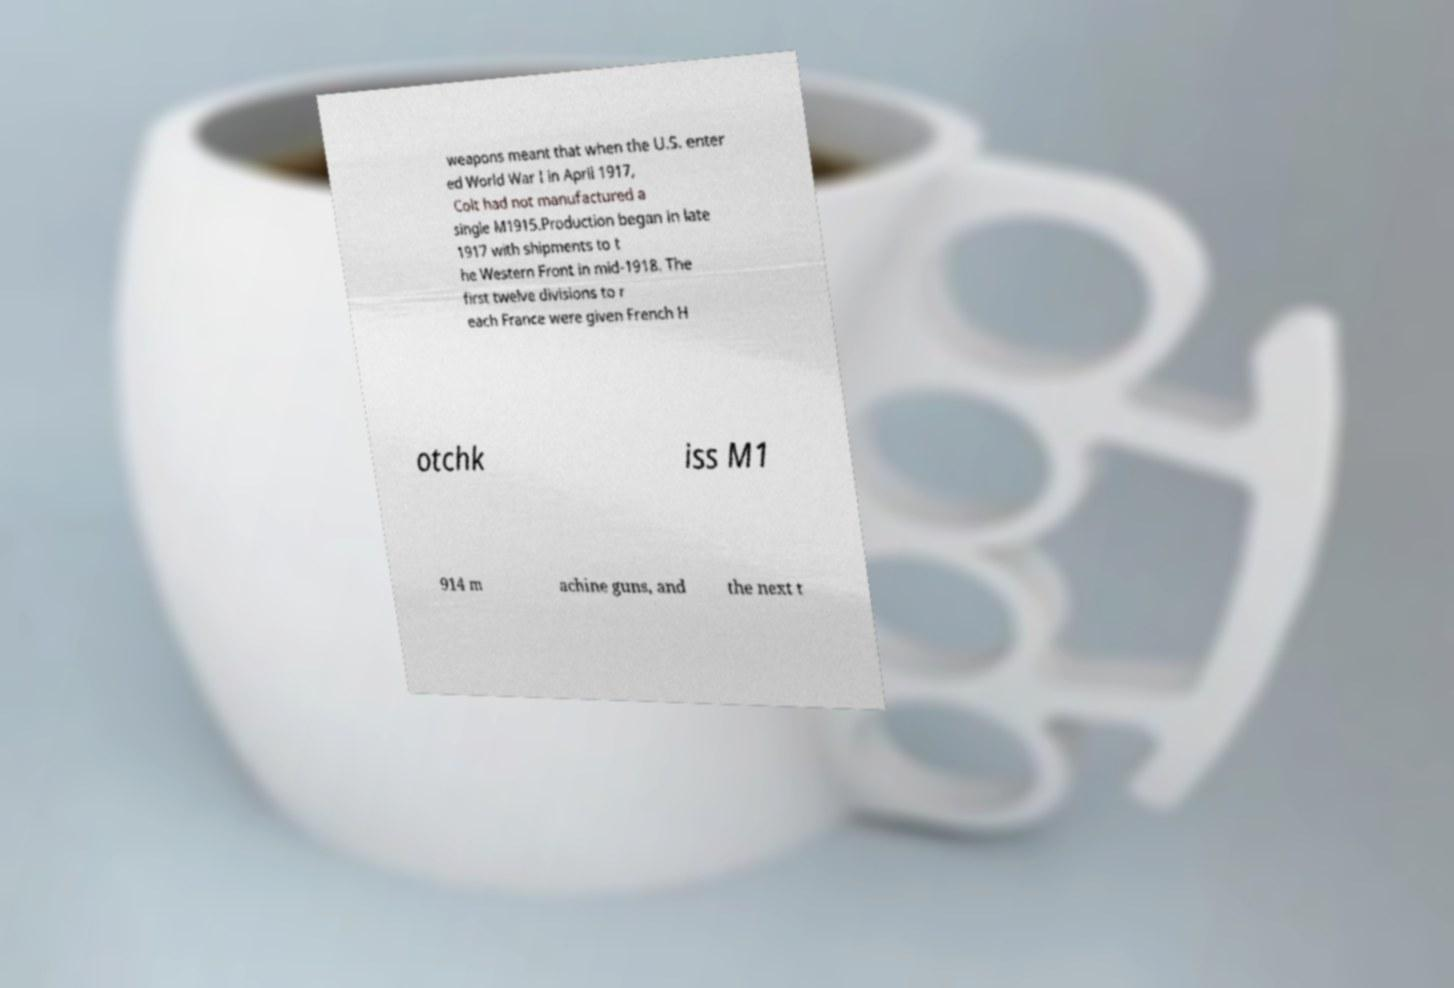What messages or text are displayed in this image? I need them in a readable, typed format. weapons meant that when the U.S. enter ed World War I in April 1917, Colt had not manufactured a single M1915.Production began in late 1917 with shipments to t he Western Front in mid-1918. The first twelve divisions to r each France were given French H otchk iss M1 914 m achine guns, and the next t 